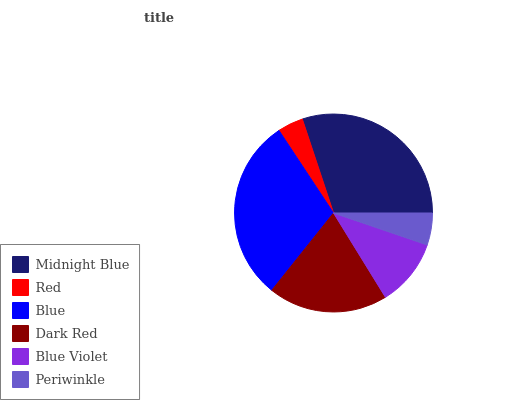Is Red the minimum?
Answer yes or no. Yes. Is Midnight Blue the maximum?
Answer yes or no. Yes. Is Blue the minimum?
Answer yes or no. No. Is Blue the maximum?
Answer yes or no. No. Is Blue greater than Red?
Answer yes or no. Yes. Is Red less than Blue?
Answer yes or no. Yes. Is Red greater than Blue?
Answer yes or no. No. Is Blue less than Red?
Answer yes or no. No. Is Dark Red the high median?
Answer yes or no. Yes. Is Blue Violet the low median?
Answer yes or no. Yes. Is Blue the high median?
Answer yes or no. No. Is Midnight Blue the low median?
Answer yes or no. No. 